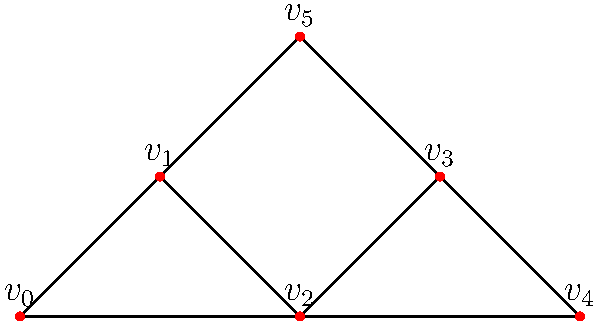As an Internet promotional planner, you're analyzing a social network to identify key opinion leaders. The graph represents users (vertices) and their connections (edges). Calculate the betweenness centrality for vertex $v_2$ to determine its influence as a potential key opinion leader. Round your answer to two decimal places. To calculate the betweenness centrality for $v_2$, we need to follow these steps:

1. Identify all pairs of vertices that have shortest paths passing through $v_2$.
2. For each pair, calculate the fraction of shortest paths that pass through $v_2$.
3. Sum up all these fractions.

Let's go through each pair:

$(v_0, v_3)$: 1 path through $v_2$ out of 1 total path. Fraction: 1
$(v_0, v_4)$: 1 path through $v_2$ out of 1 total path. Fraction: 1
$(v_0, v_5)$: 1 path through $v_2$ out of 2 total paths. Fraction: 1/2
$(v_1, v_4)$: 1 path through $v_2$ out of 1 total path. Fraction: 1

Sum of fractions: $1 + 1 + 0.5 + 1 = 3.5$

The betweenness centrality is then normalized by dividing by the number of possible vertex pairs excluding $v_2$:

$\text{Number of pairs} = \frac{(n-1)(n-2)}{2} = \frac{(6-1)(6-2)}{2} = 10$

Normalized betweenness centrality: $3.5 / 10 = 0.35$

Rounded to two decimal places: 0.35
Answer: 0.35 